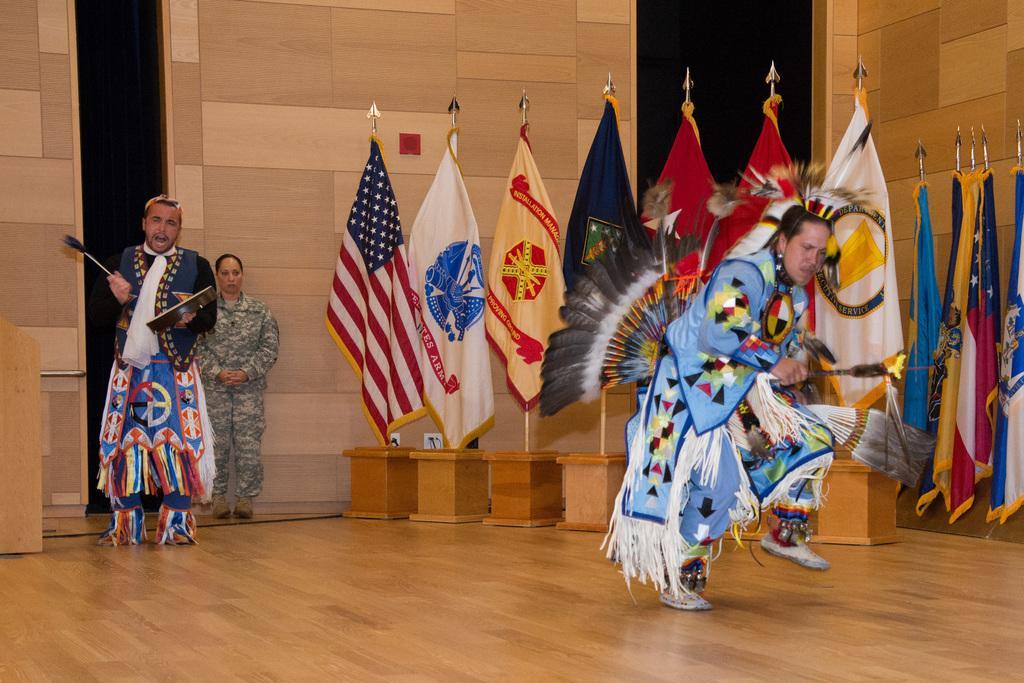How would you summarize this image in a sentence or two? In the image we can see there are people wearing clothes and shoes. This is a wooden floor, wooden wall, flags of the countries, feathers and a wooden box. 